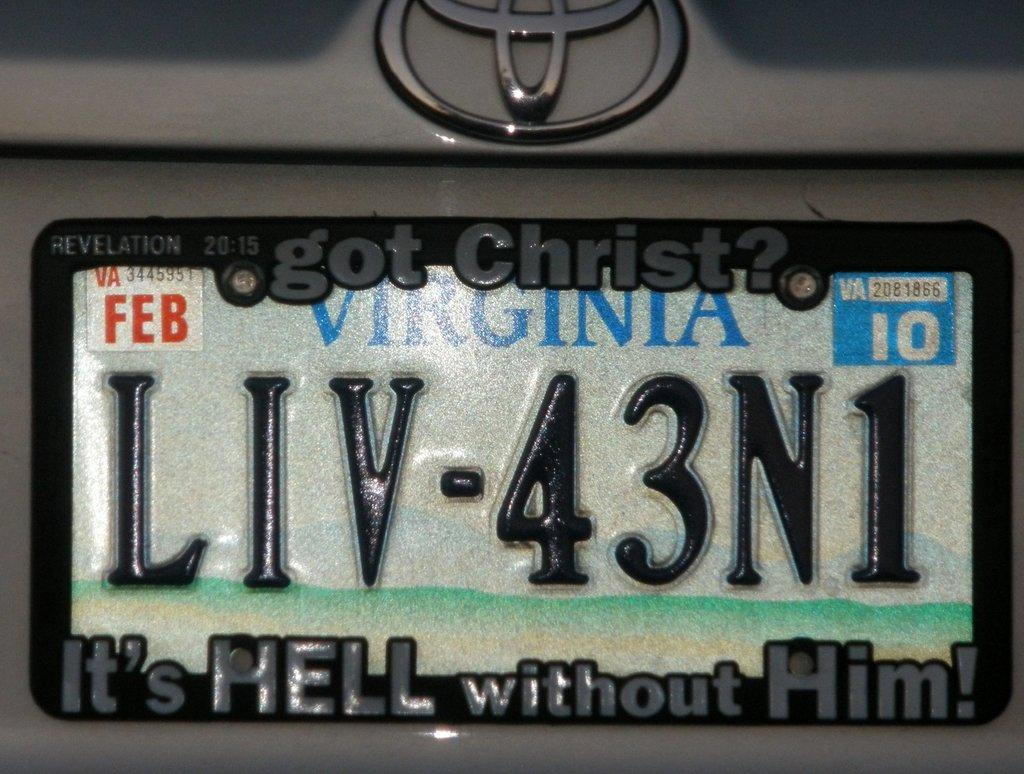<image>
Create a compact narrative representing the image presented. A Virginia license plate says Got Christ It's Hell without Him. 